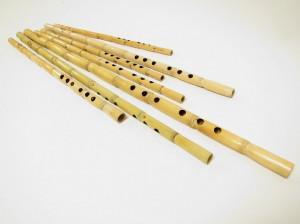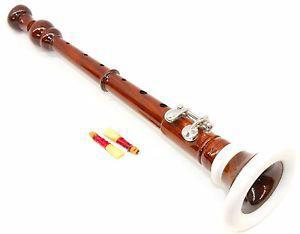The first image is the image on the left, the second image is the image on the right. For the images shown, is this caption "There are two very dark colored flutes." true? Answer yes or no. No. The first image is the image on the left, the second image is the image on the right. Assess this claim about the two images: "Each image contains exactly one dark flute with metal keys.". Correct or not? Answer yes or no. No. 